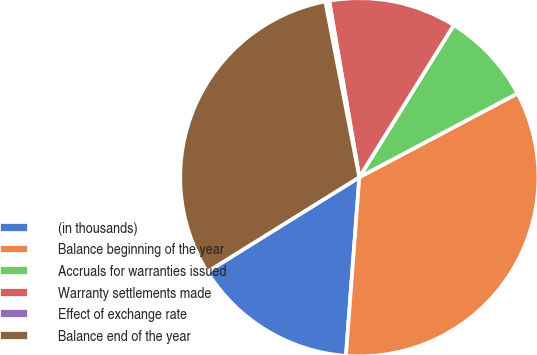Convert chart to OTSL. <chart><loc_0><loc_0><loc_500><loc_500><pie_chart><fcel>(in thousands)<fcel>Balance beginning of the year<fcel>Accruals for warranties issued<fcel>Warranty settlements made<fcel>Effect of exchange rate<fcel>Balance end of the year<nl><fcel>14.95%<fcel>33.95%<fcel>8.4%<fcel>11.54%<fcel>0.35%<fcel>30.81%<nl></chart> 